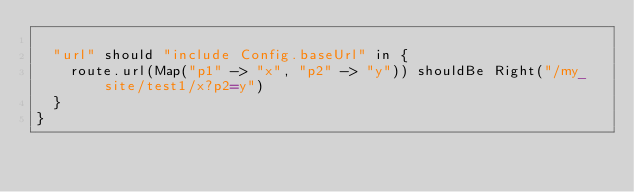<code> <loc_0><loc_0><loc_500><loc_500><_Scala_>
  "url" should "include Config.baseUrl" in {
    route.url(Map("p1" -> "x", "p2" -> "y")) shouldBe Right("/my_site/test1/x?p2=y")
  }
}
</code> 